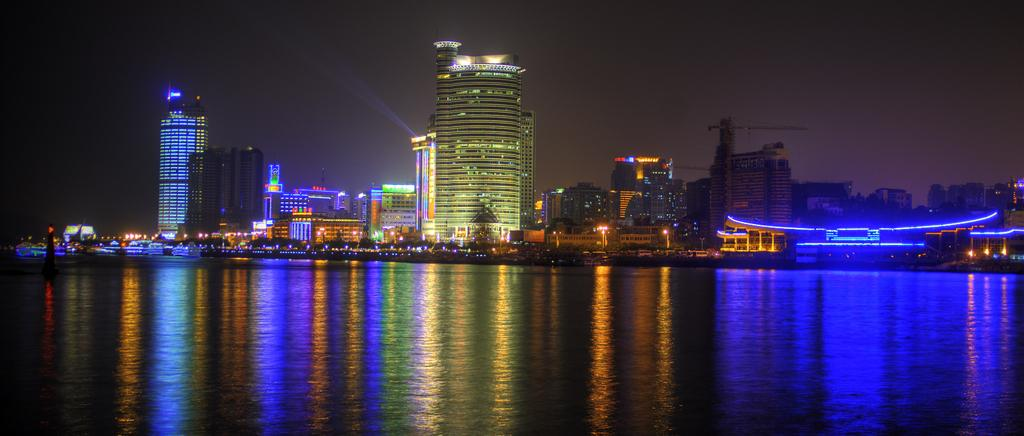What is present at the bottom of the image? There is water at the bottom of the image. What can be seen in the middle of the image? There are buildings and poles in the middle of the image. What type of disease is affecting the buildings in the image? There is no indication of any disease affecting the buildings in the image. How does the pain manifest in the poles in the image? There is no pain associated with the poles in the image. 